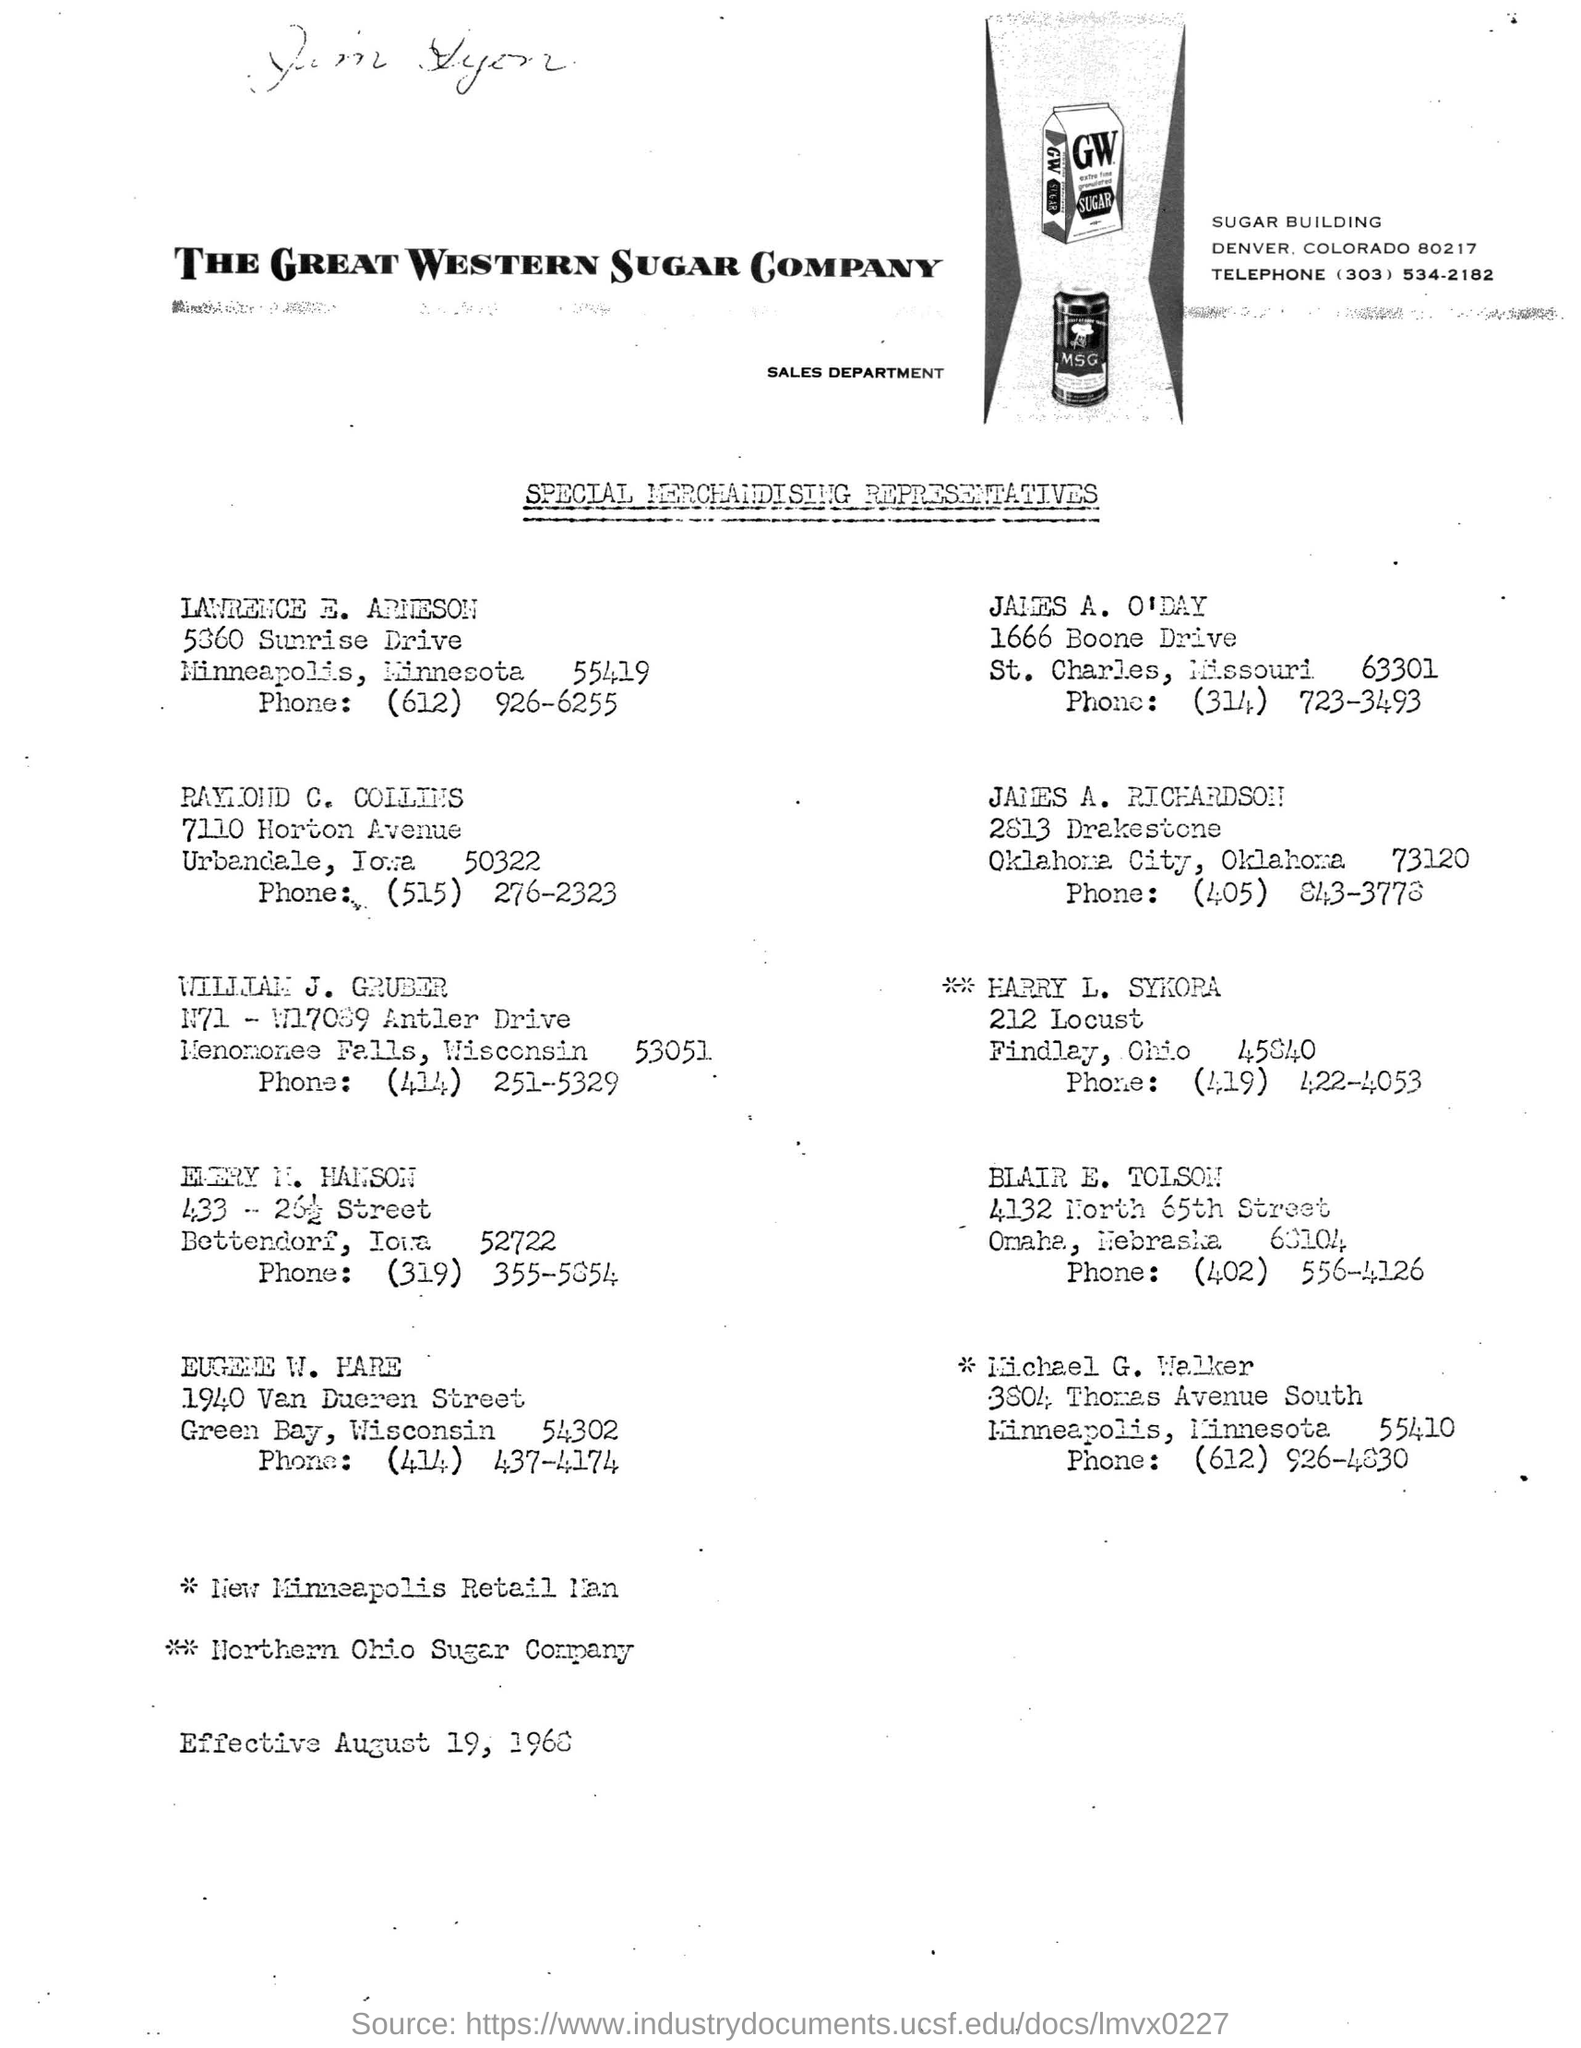What is the name of the building mentioned ?
Provide a short and direct response. SUGAR. What is the name of the department mentioned ?
Give a very brief answer. SALES DEPARTMENT. What is the name of the company mentioned ?
Ensure brevity in your answer.  The Great Western Sugar Company. 